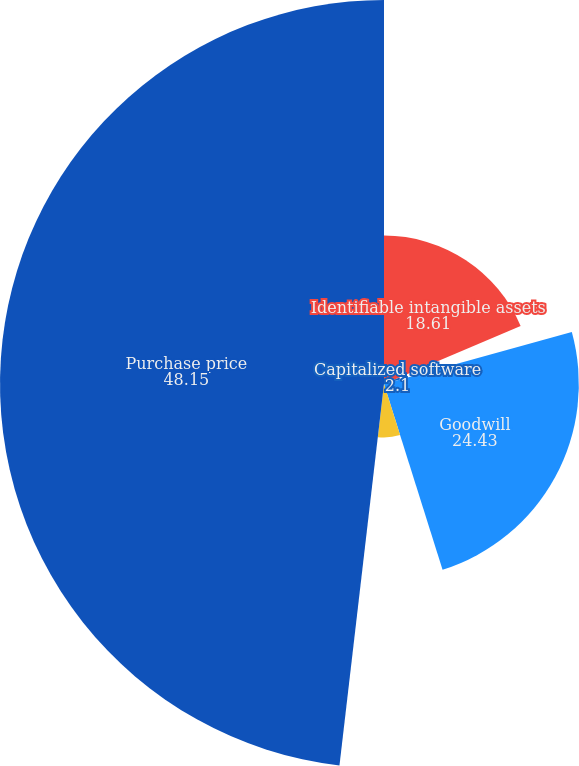<chart> <loc_0><loc_0><loc_500><loc_500><pie_chart><fcel>Identifiable intangible assets<fcel>Capitalized software<fcel>Goodwill<fcel>Other net assets (liabilities)<fcel>Purchase price<nl><fcel>18.61%<fcel>2.1%<fcel>24.43%<fcel>6.71%<fcel>48.15%<nl></chart> 